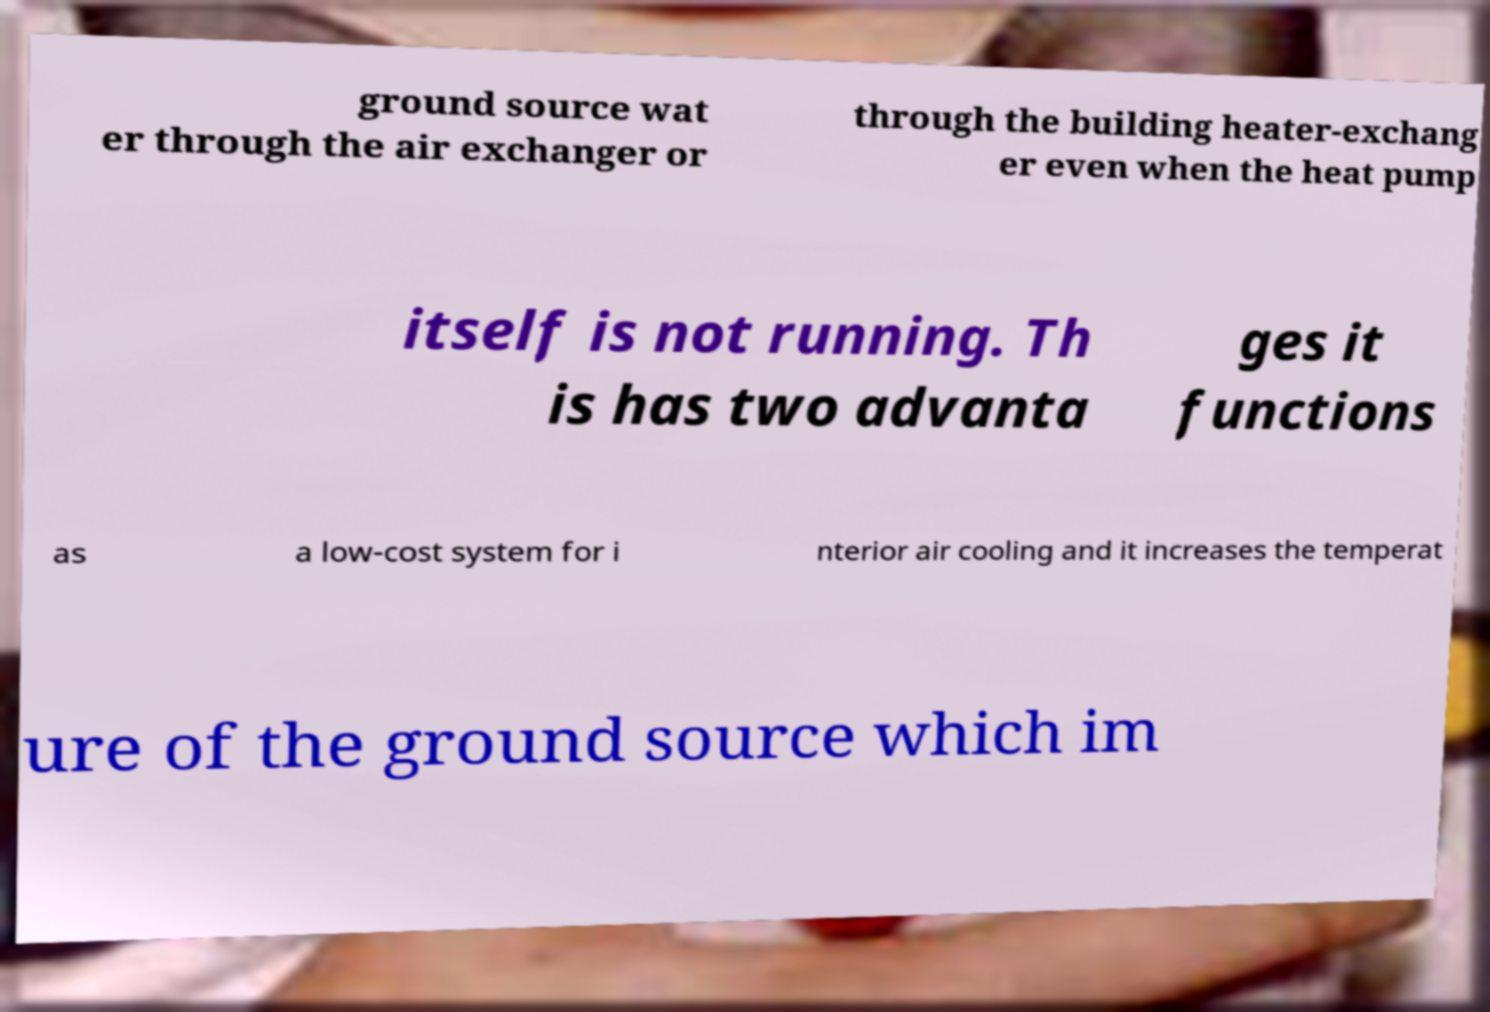There's text embedded in this image that I need extracted. Can you transcribe it verbatim? ground source wat er through the air exchanger or through the building heater-exchang er even when the heat pump itself is not running. Th is has two advanta ges it functions as a low-cost system for i nterior air cooling and it increases the temperat ure of the ground source which im 